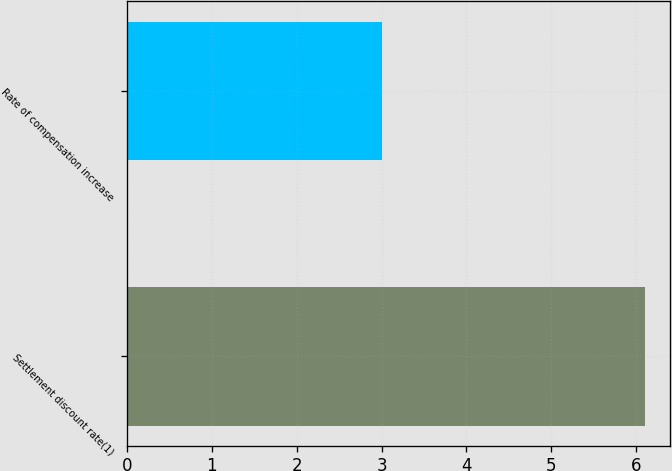<chart> <loc_0><loc_0><loc_500><loc_500><bar_chart><fcel>Settlement discount rate(1)<fcel>Rate of compensation increase<nl><fcel>6.1<fcel>3<nl></chart> 